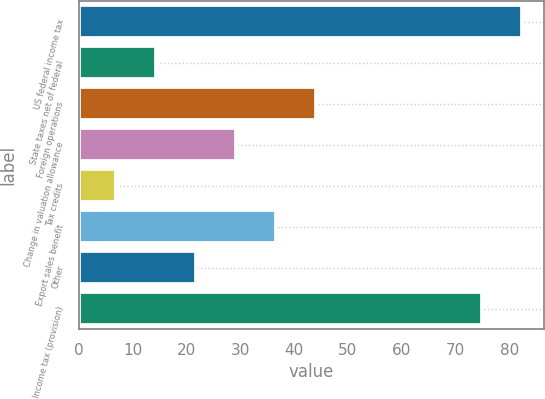<chart> <loc_0><loc_0><loc_500><loc_500><bar_chart><fcel>US federal income tax<fcel>State taxes net of federal<fcel>Foreign operations<fcel>Change in valuation allowance<fcel>Tax credits<fcel>Export sales benefit<fcel>Other<fcel>Income tax (provision)<nl><fcel>82.4<fcel>14.4<fcel>44<fcel>29.2<fcel>7<fcel>36.6<fcel>21.8<fcel>75<nl></chart> 